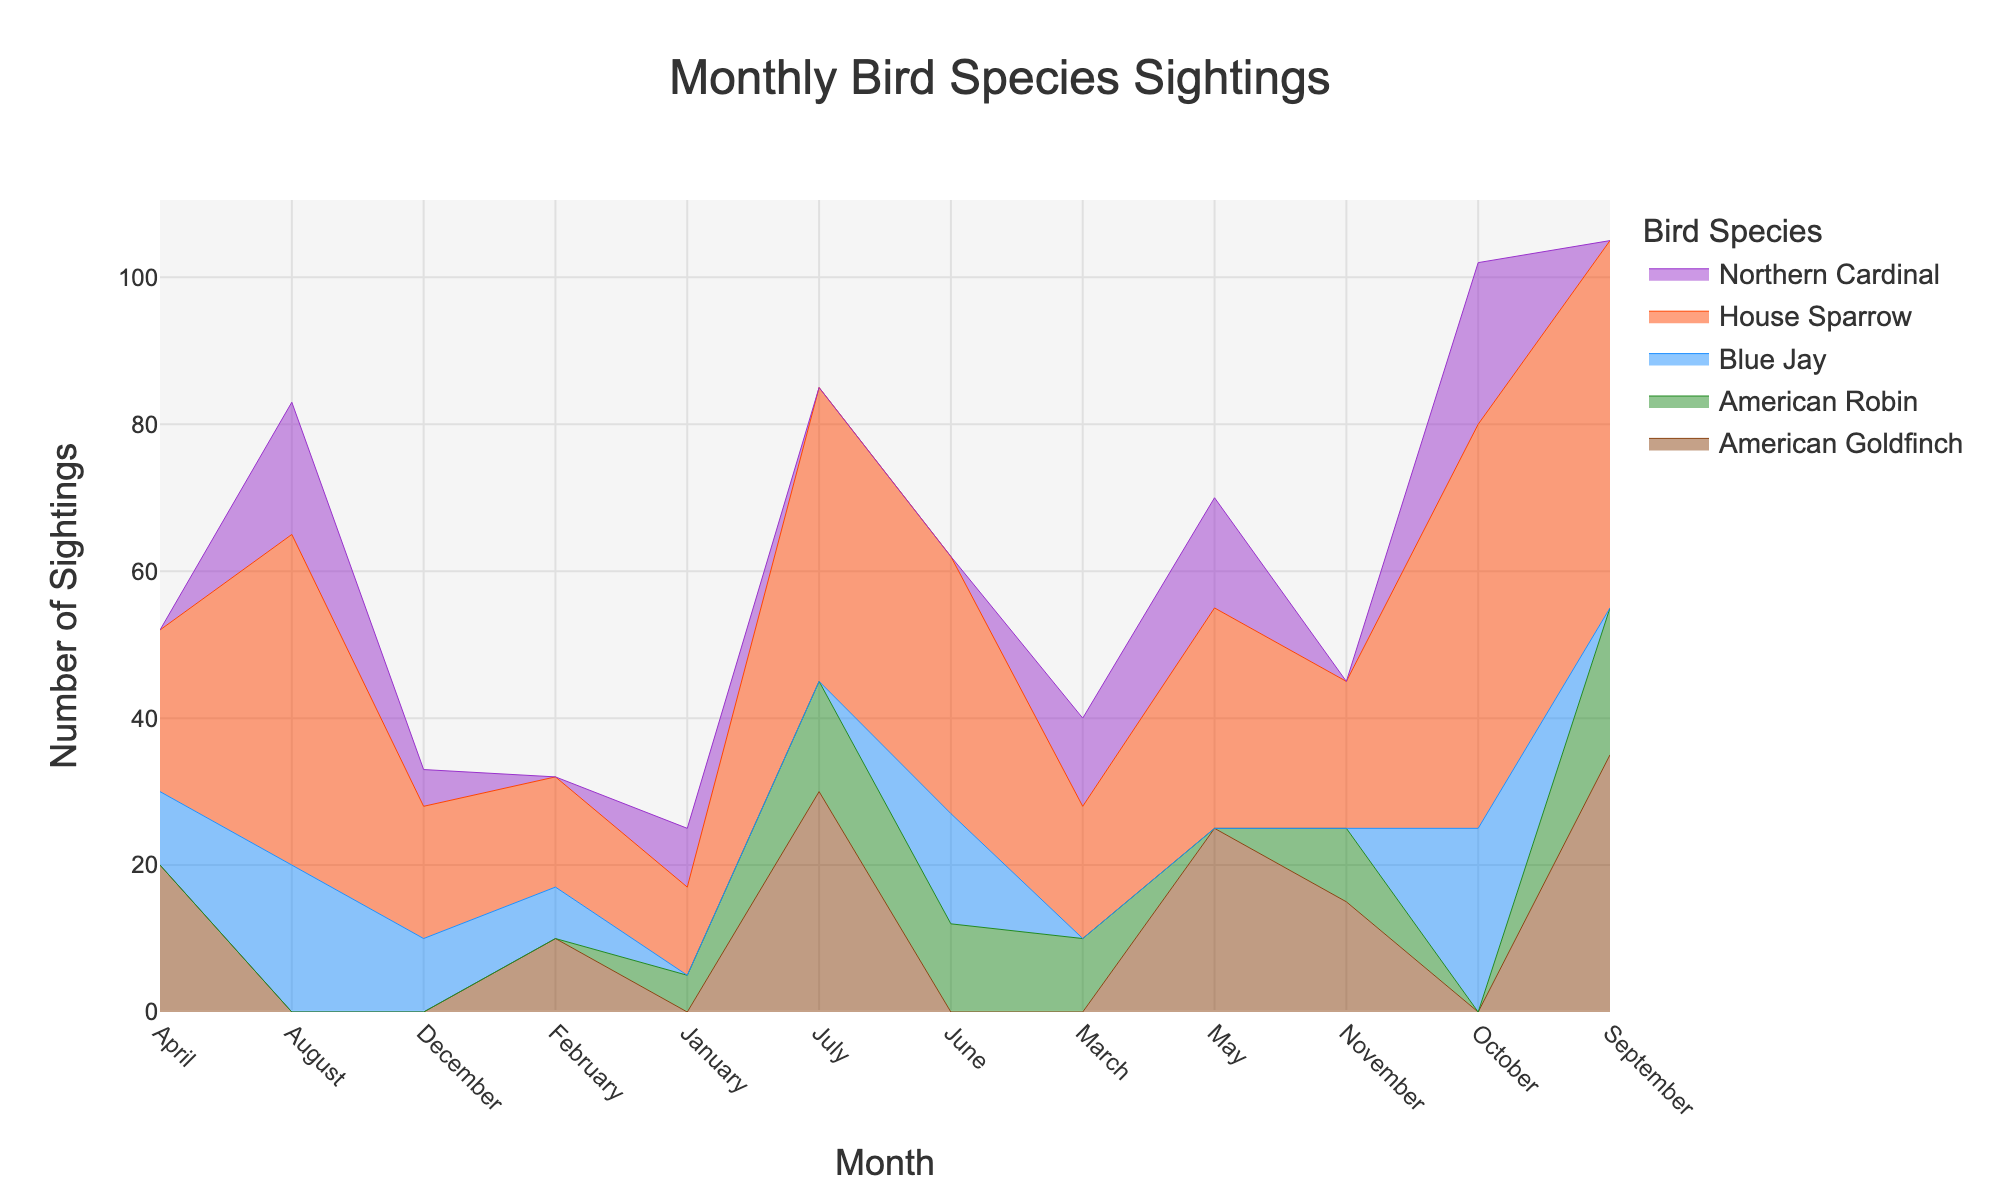What is the title of the plot? The title is located at the top center of the plot and typically describes what the data represents. From the provided details, it's "Monthly Bird Species Sightings"
Answer: Monthly Bird Species Sightings Which bird species had the highest number of sightings in October? Look at the step area corresponding to October in the plot and compare the heights of the different species. The highest step corresponds to the House Sparrow
Answer: House Sparrow How many sightings of the American Robin were there in July? Find the July data point for the color representing the American Robin. The height of this step reflects the number of sightings, which is 15
Answer: 15 Which month had the greatest total number of bird sightings? Calculate the sum of all bird sightings for each month. The month with the highest cumulative sightings will be the answer. September has the most with American Robin (20) + American Goldfinch (35) + House Sparrow (50), totaling 105
Answer: September How many sightings of the House Sparrow were there in April? Locate the data for the House Sparrow in April. The height of its area step represents the number of incidents, which is 22
Answer: 22 What trend do you observe for the sightings of the American Goldfinch over the months? Observe the steps of the American Goldfinch's area. Its sightings increase from February to July, then decrease after September
Answer: Increasing until July, then decreasing In which month did the Blue Jay have the least sightings, and how many? Compare the heights of all monthly steps for Blue Jay. February readings show the lowest sightings, with 7 incidents
Answer: February, 7 By how much did sightings of the House Sparrow increase from January to December? Check the initial and final values for the House Sparrow's area step. January had 12 sightings, while December had 18, showing an increase of 6
Answer: 6 Which two species had the closest number of sightings in March? Compare the step heights of all species in March. The American Robin and Northern Cardinal are close, with 10 and 12 sightings respectively, differing by 2
Answer: American Robin and Northern Cardinal What was the cumulative number of sightings for the Northern Cardinal over the year? Sum the sightings of the Northern Cardinal across all months: 8 (Jan) + 12 (Mar) + 15 (May) + 18 (Aug) + 22 (Oct) + 5 (Dec) = 80
Answer: 80 